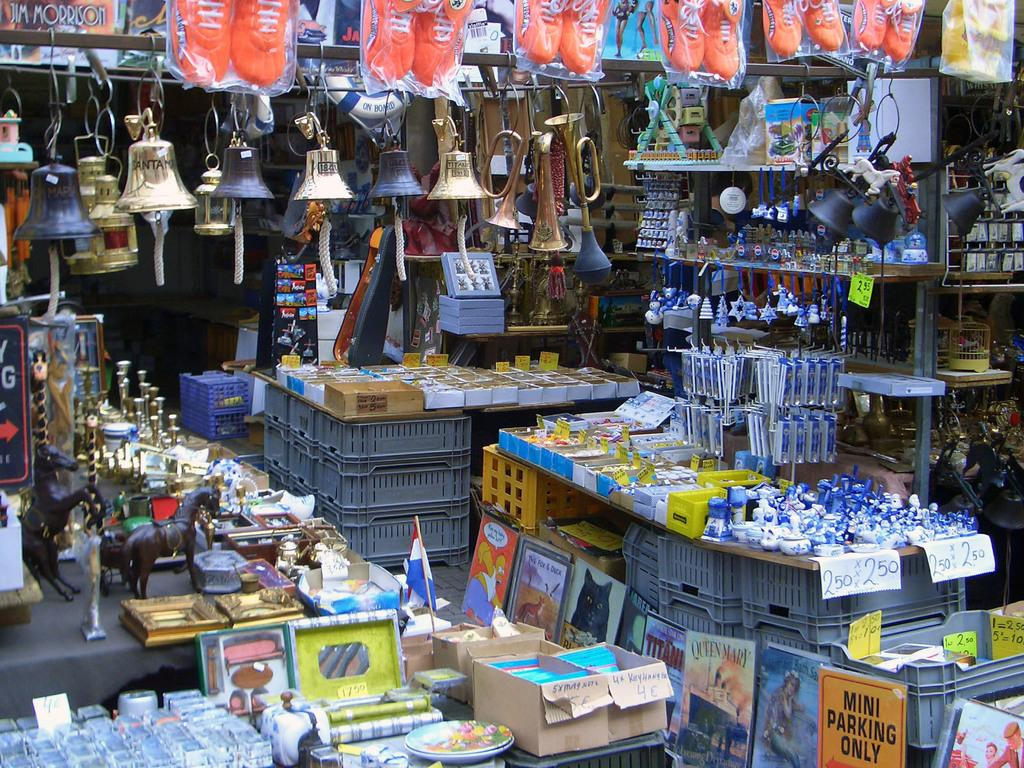<image>
Summarize the visual content of the image. A store filled with goods including a sign saying "Mini Parking Only". 